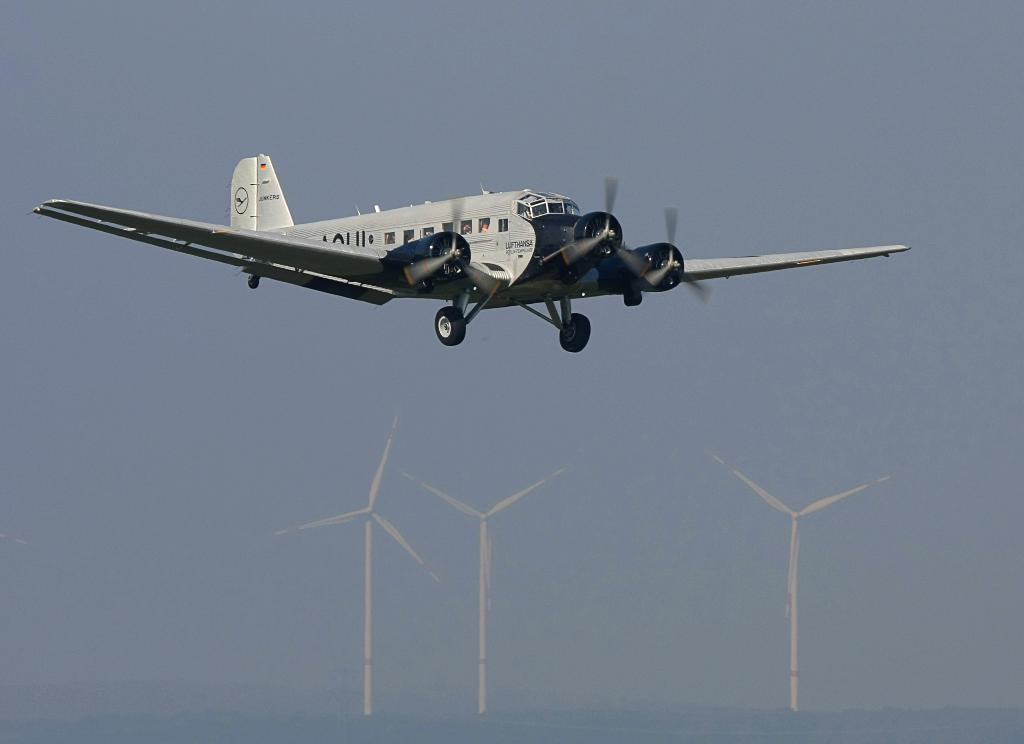What is the main subject of the image? The main subject of the image is an aircraft. What other objects can be seen in the image? There are windmills visible in the image. What is visible in the background of the image? The sky is visible in the background of the image. What type of limit is being tested by the aircraft in the image? There is no indication in the image that the aircraft is being used to test any limits. Can you tell me how many basins are visible in the image? There are no basins present in the image. What angle is the aircraft positioned at in the image? The angle at which the aircraft is positioned cannot be determined from the image alone. 